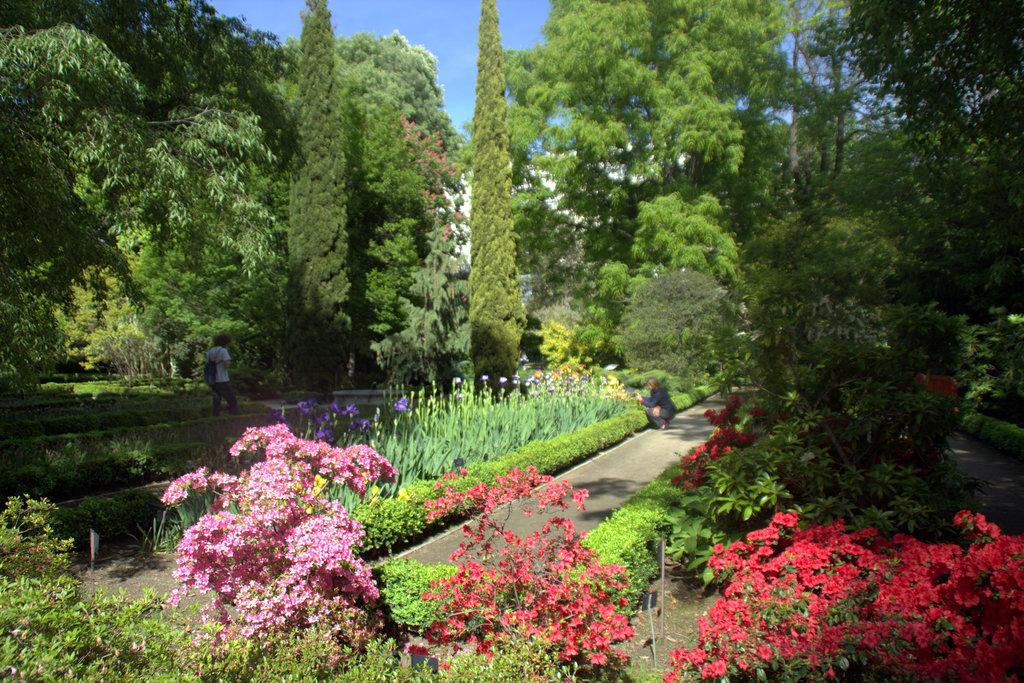What type of plants can be seen in the image? There are flowering plants in the image. Can you describe the people in the image? There are two persons on the road in the image. What can be seen in the background of the image? There are trees and the sky visible in the background of the image. What time of day might the image have been taken? The image appears to be taken during the day. What is the possible location of the image? The location may be a park. What is the name of the list that the flowering plants are holding in the image? There are no lists or names associated with the flowering plants in the image; they are simply plants. 